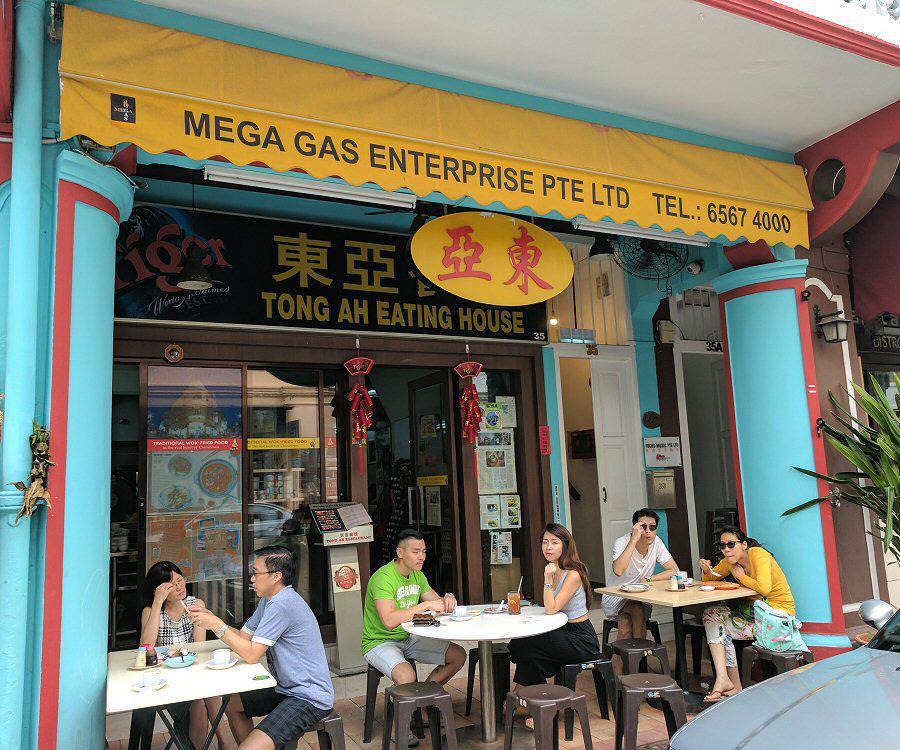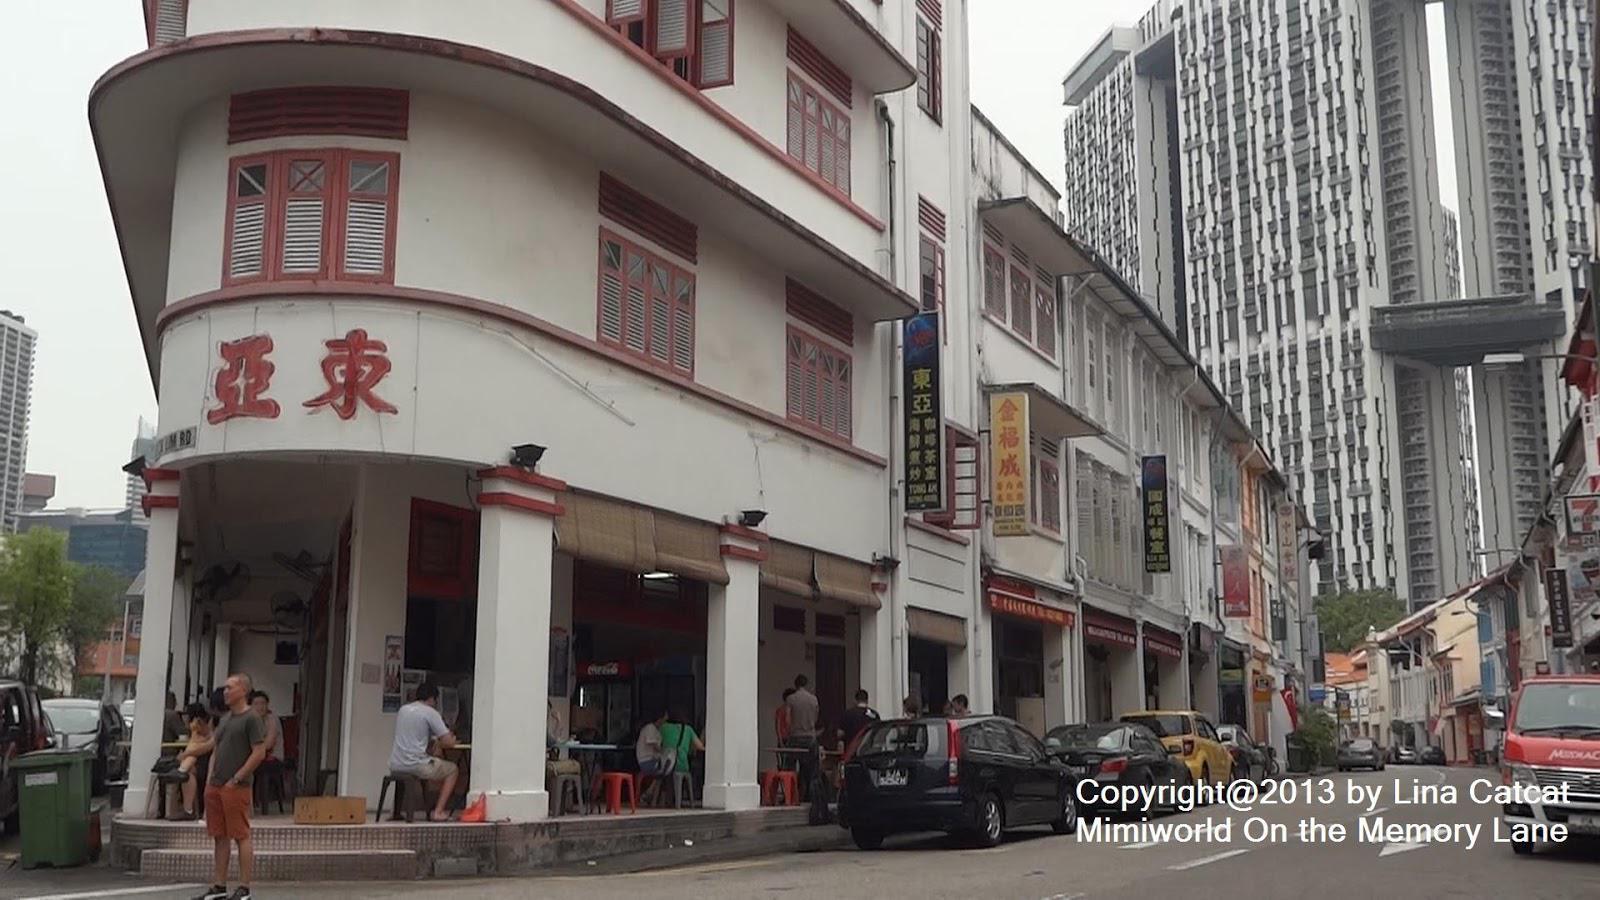The first image is the image on the left, the second image is the image on the right. Analyze the images presented: Is the assertion "Left and right images show the same red-trimmed white building which curves around the corner with a row of columns." valid? Answer yes or no. No. The first image is the image on the left, the second image is the image on the right. For the images displayed, is the sentence "There is a yellow sign above the door with asian lettering" factually correct? Answer yes or no. Yes. 